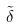<formula> <loc_0><loc_0><loc_500><loc_500>\tilde { \delta }</formula> 